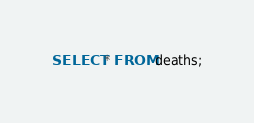<code> <loc_0><loc_0><loc_500><loc_500><_SQL_>SELECT * FROM deaths;</code> 